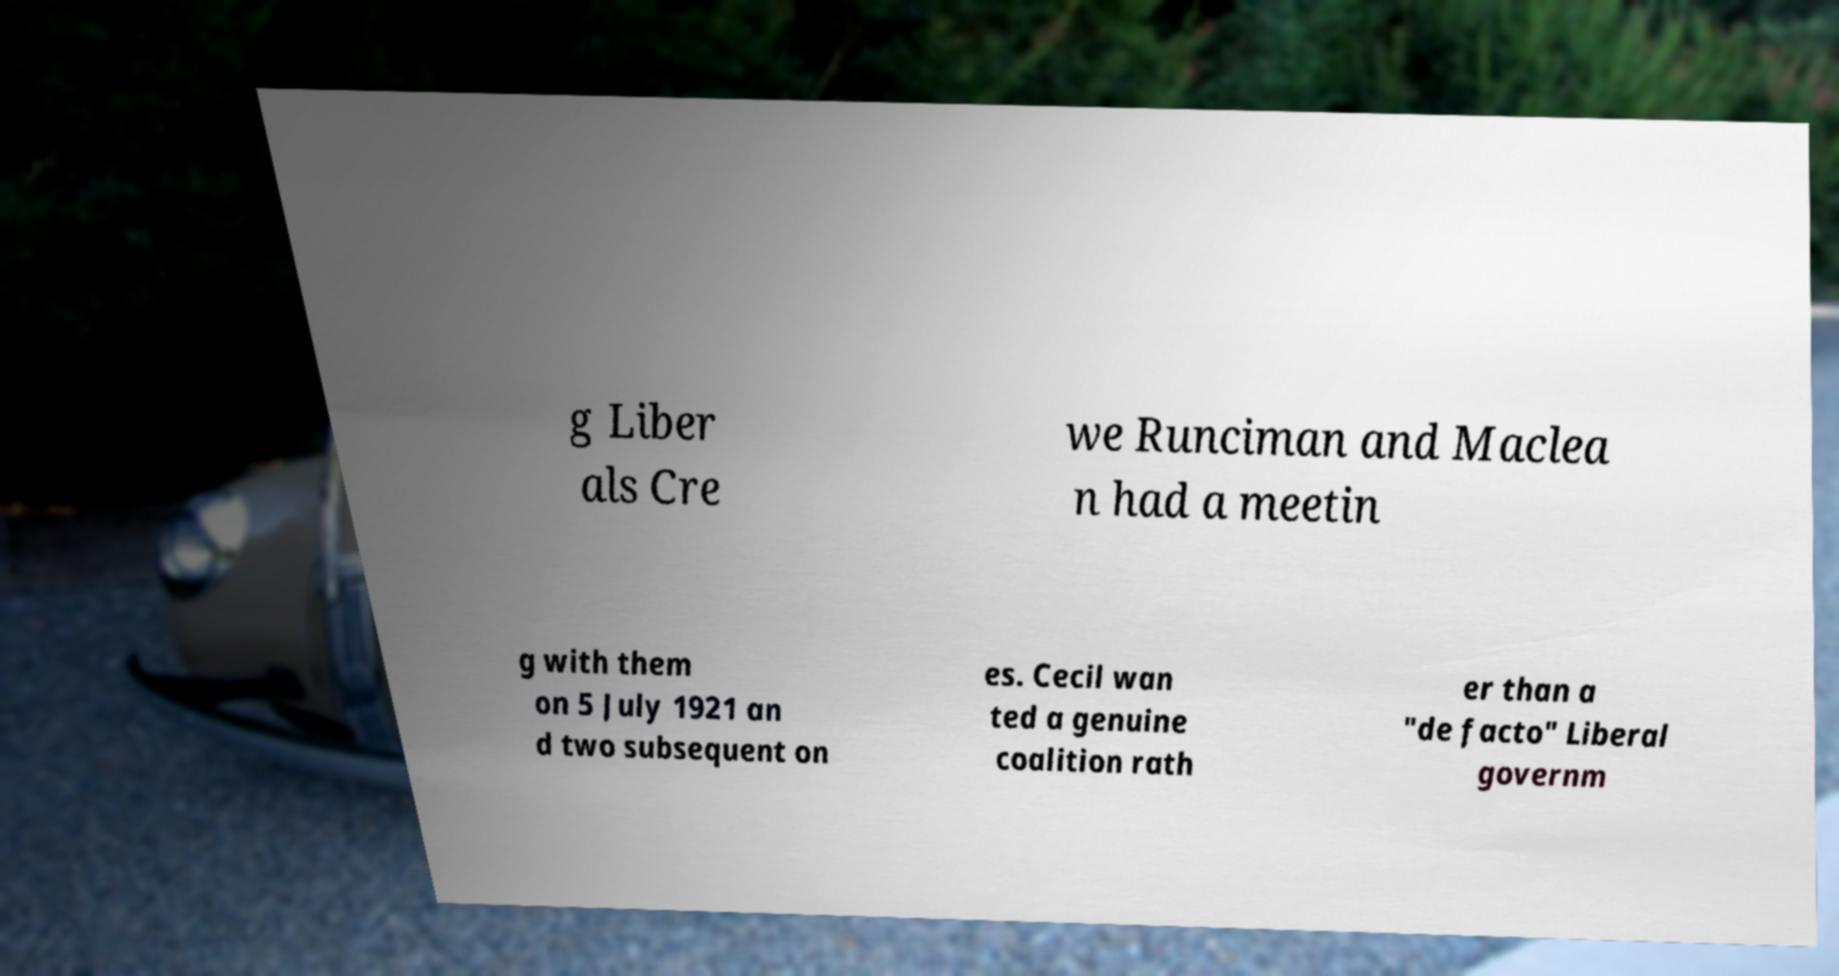There's text embedded in this image that I need extracted. Can you transcribe it verbatim? g Liber als Cre we Runciman and Maclea n had a meetin g with them on 5 July 1921 an d two subsequent on es. Cecil wan ted a genuine coalition rath er than a "de facto" Liberal governm 